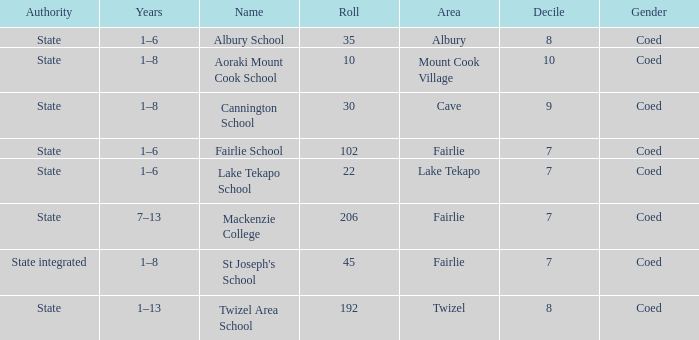What area is named Mackenzie college? Fairlie. 